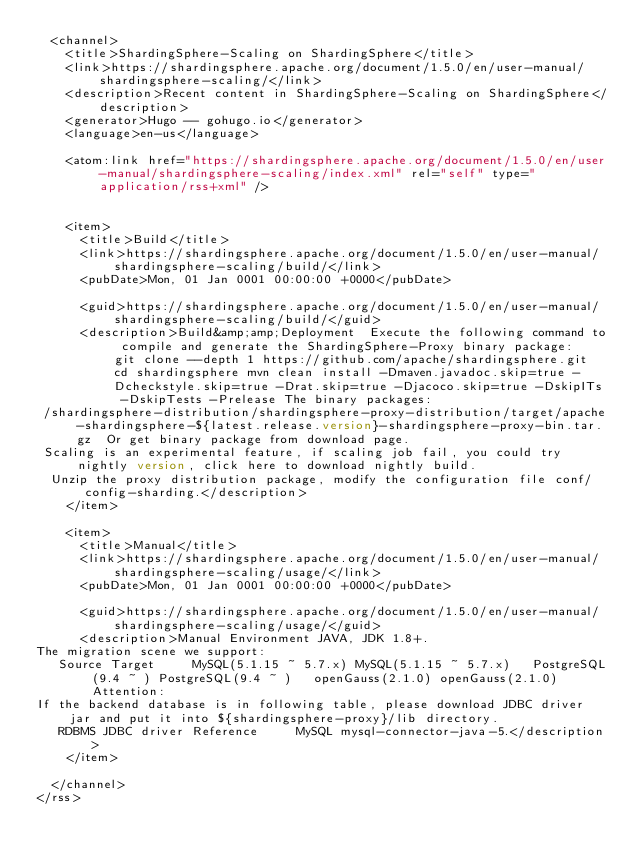<code> <loc_0><loc_0><loc_500><loc_500><_XML_>  <channel>
    <title>ShardingSphere-Scaling on ShardingSphere</title>
    <link>https://shardingsphere.apache.org/document/1.5.0/en/user-manual/shardingsphere-scaling/</link>
    <description>Recent content in ShardingSphere-Scaling on ShardingSphere</description>
    <generator>Hugo -- gohugo.io</generator>
    <language>en-us</language>
    
	<atom:link href="https://shardingsphere.apache.org/document/1.5.0/en/user-manual/shardingsphere-scaling/index.xml" rel="self" type="application/rss+xml" />
    
    
    <item>
      <title>Build</title>
      <link>https://shardingsphere.apache.org/document/1.5.0/en/user-manual/shardingsphere-scaling/build/</link>
      <pubDate>Mon, 01 Jan 0001 00:00:00 +0000</pubDate>
      
      <guid>https://shardingsphere.apache.org/document/1.5.0/en/user-manual/shardingsphere-scaling/build/</guid>
      <description>Build&amp;amp;Deployment  Execute the following command to compile and generate the ShardingSphere-Proxy binary package:  git clone --depth 1 https://github.com/apache/shardingsphere.git cd shardingsphere mvn clean install -Dmaven.javadoc.skip=true -Dcheckstyle.skip=true -Drat.skip=true -Djacoco.skip=true -DskipITs -DskipTests -Prelease The binary packages:
 /shardingsphere-distribution/shardingsphere-proxy-distribution/target/apache-shardingsphere-${latest.release.version}-shardingsphere-proxy-bin.tar.gz  Or get binary package from download page.
 Scaling is an experimental feature, if scaling job fail, you could try nightly version, click here to download nightly build.
  Unzip the proxy distribution package, modify the configuration file conf/config-sharding.</description>
    </item>
    
    <item>
      <title>Manual</title>
      <link>https://shardingsphere.apache.org/document/1.5.0/en/user-manual/shardingsphere-scaling/usage/</link>
      <pubDate>Mon, 01 Jan 0001 00:00:00 +0000</pubDate>
      
      <guid>https://shardingsphere.apache.org/document/1.5.0/en/user-manual/shardingsphere-scaling/usage/</guid>
      <description>Manual Environment JAVA, JDK 1.8+.
The migration scene we support:
   Source Target     MySQL(5.1.15 ~ 5.7.x) MySQL(5.1.15 ~ 5.7.x)   PostgreSQL(9.4 ~ ) PostgreSQL(9.4 ~ )   openGauss(2.1.0) openGauss(2.1.0)    Attention:
If the backend database is in following table, please download JDBC driver jar and put it into ${shardingsphere-proxy}/lib directory.
   RDBMS JDBC driver Reference     MySQL mysql-connector-java-5.</description>
    </item>
    
  </channel>
</rss></code> 